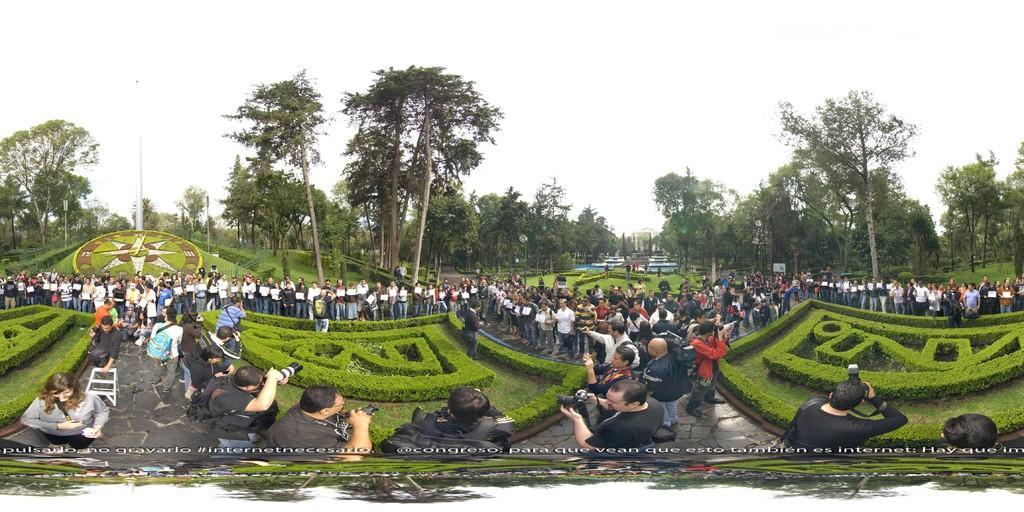Describe this image in one or two sentences. At the bottom of the image few people are standing and holding some cameras and bags. Behind them we can see grass and trees. At the top of the image we can see the sky. 